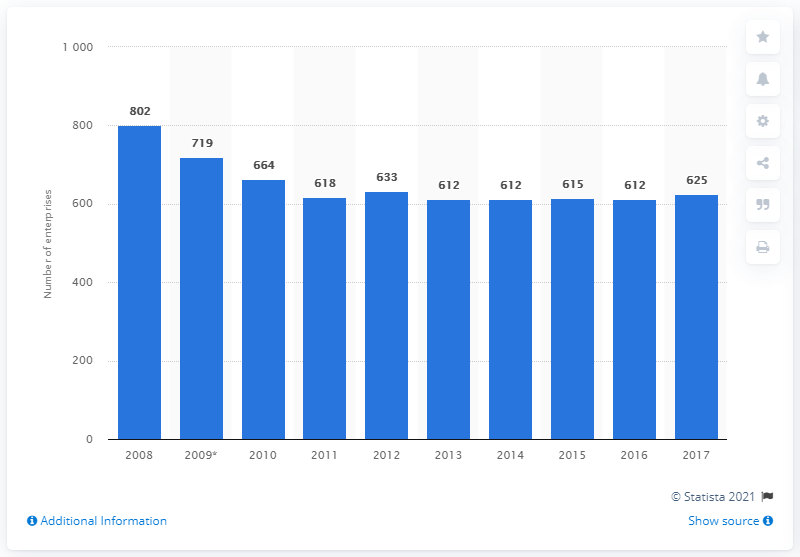List a handful of essential elements in this visual. In 2017, there were 625 enterprises in Romania that manufactured electronic components. 